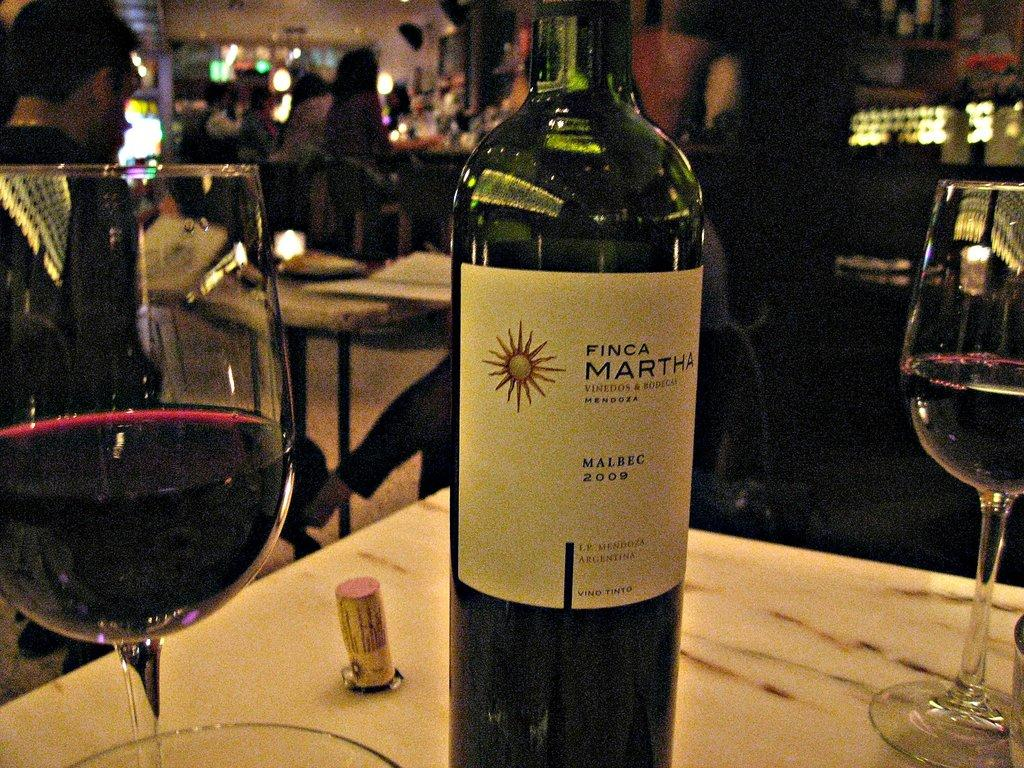What is located in the middle of the image? There is a table in the middle of the image. What objects are on the table? There are glasses and a bottle on the table. What can be seen in the background of the image? There are people, other tables, lights, and a wall in the background. What word is written on the roof in the image? There is no word written on a roof in the image, as there is no roof visible in the image. 